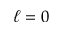<formula> <loc_0><loc_0><loc_500><loc_500>\ell = 0</formula> 